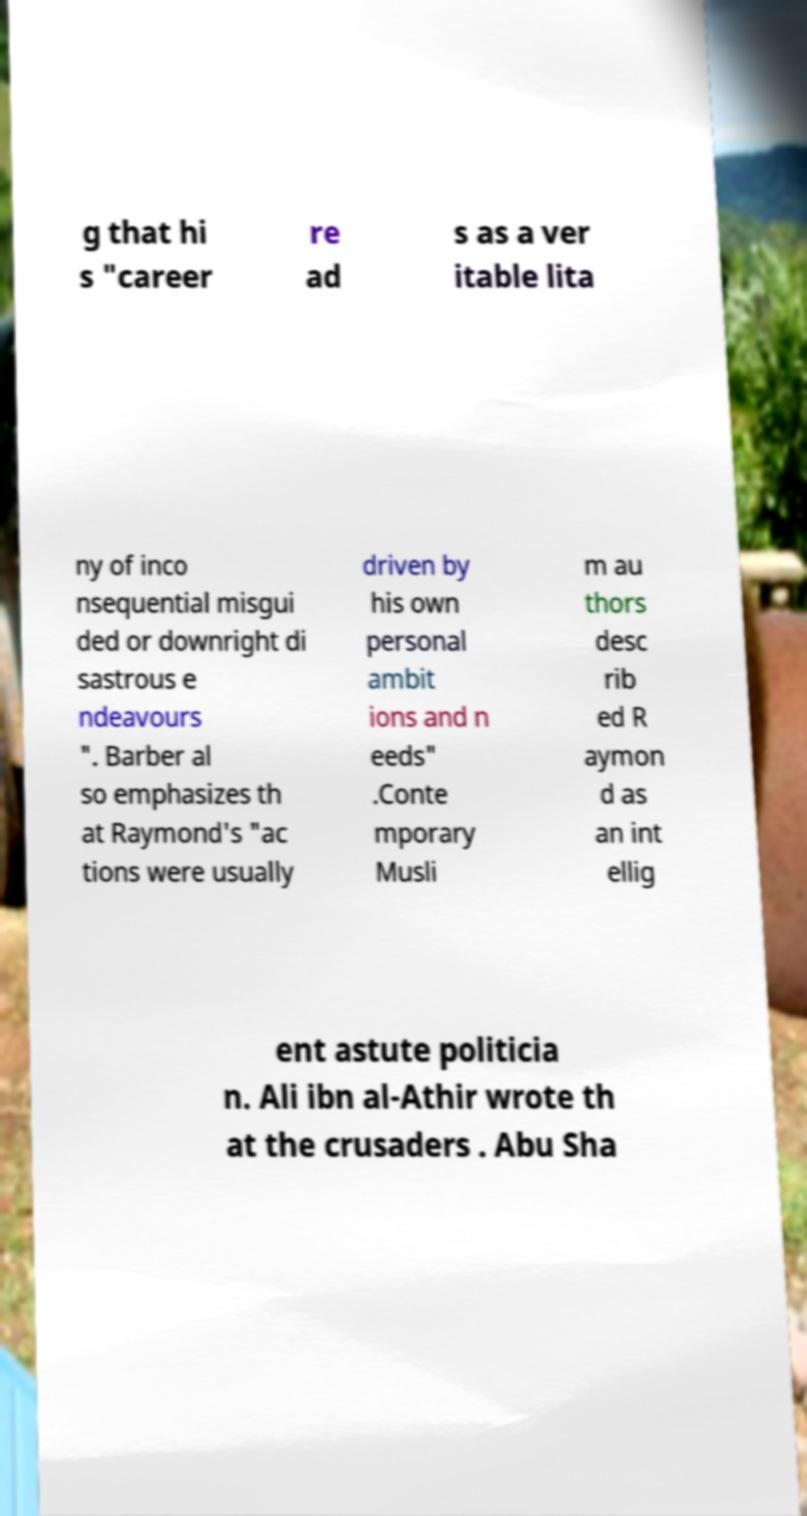For documentation purposes, I need the text within this image transcribed. Could you provide that? g that hi s "career re ad s as a ver itable lita ny of inco nsequential misgui ded or downright di sastrous e ndeavours ". Barber al so emphasizes th at Raymond's "ac tions were usually driven by his own personal ambit ions and n eeds" .Conte mporary Musli m au thors desc rib ed R aymon d as an int ellig ent astute politicia n. Ali ibn al-Athir wrote th at the crusaders . Abu Sha 